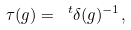Convert formula to latex. <formula><loc_0><loc_0><loc_500><loc_500>\tau ( g ) = \ ^ { t } \delta ( g ) ^ { - 1 } ,</formula> 